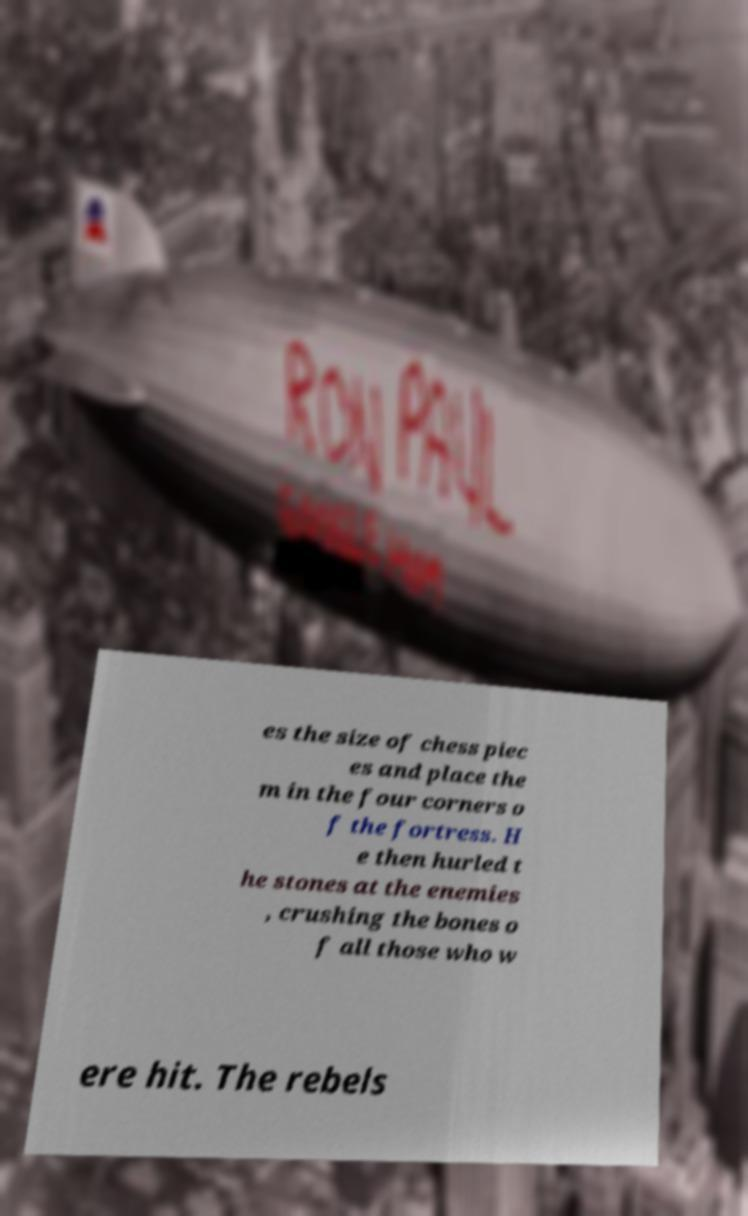What messages or text are displayed in this image? I need them in a readable, typed format. es the size of chess piec es and place the m in the four corners o f the fortress. H e then hurled t he stones at the enemies , crushing the bones o f all those who w ere hit. The rebels 